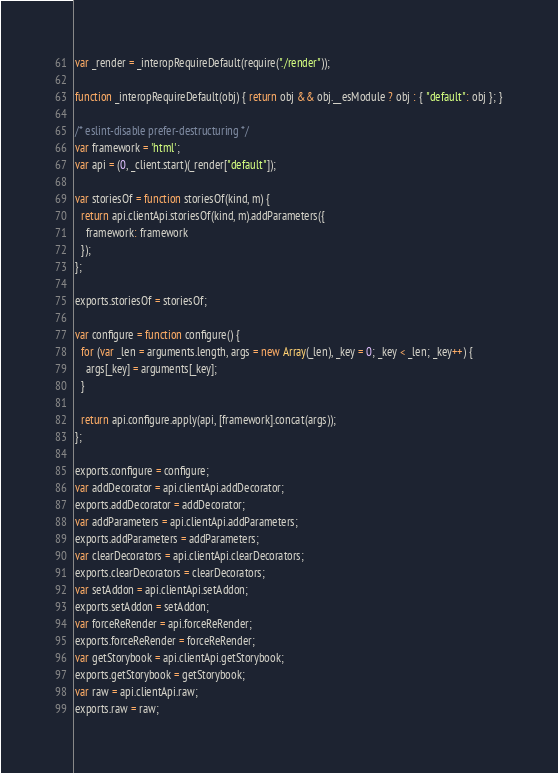<code> <loc_0><loc_0><loc_500><loc_500><_JavaScript_>
var _render = _interopRequireDefault(require("./render"));

function _interopRequireDefault(obj) { return obj && obj.__esModule ? obj : { "default": obj }; }

/* eslint-disable prefer-destructuring */
var framework = 'html';
var api = (0, _client.start)(_render["default"]);

var storiesOf = function storiesOf(kind, m) {
  return api.clientApi.storiesOf(kind, m).addParameters({
    framework: framework
  });
};

exports.storiesOf = storiesOf;

var configure = function configure() {
  for (var _len = arguments.length, args = new Array(_len), _key = 0; _key < _len; _key++) {
    args[_key] = arguments[_key];
  }

  return api.configure.apply(api, [framework].concat(args));
};

exports.configure = configure;
var addDecorator = api.clientApi.addDecorator;
exports.addDecorator = addDecorator;
var addParameters = api.clientApi.addParameters;
exports.addParameters = addParameters;
var clearDecorators = api.clientApi.clearDecorators;
exports.clearDecorators = clearDecorators;
var setAddon = api.clientApi.setAddon;
exports.setAddon = setAddon;
var forceReRender = api.forceReRender;
exports.forceReRender = forceReRender;
var getStorybook = api.clientApi.getStorybook;
exports.getStorybook = getStorybook;
var raw = api.clientApi.raw;
exports.raw = raw;</code> 